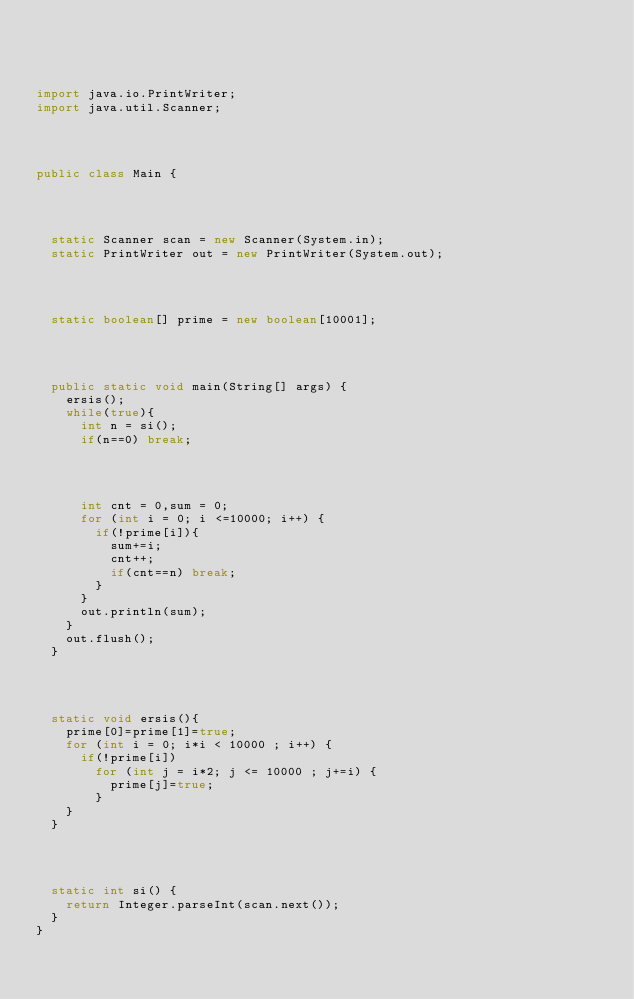<code> <loc_0><loc_0><loc_500><loc_500><_Java_>



import java.io.PrintWriter;
import java.util.Scanner;




public class Main {




	static Scanner scan = new Scanner(System.in);
	static PrintWriter out = new PrintWriter(System.out);




	static boolean[] prime = new boolean[10001];




	public static void main(String[] args) {
		ersis();
		while(true){
			int n = si();
			if(n==0) break;




			int cnt = 0,sum = 0;
			for (int i = 0; i <=10000; i++) {
				if(!prime[i]){
					sum+=i;
					cnt++;
					if(cnt==n) break;
				}
			}
			out.println(sum);
		}
		out.flush();
	}




	static void ersis(){
		prime[0]=prime[1]=true;
		for (int i = 0; i*i < 10000 ; i++) {
			if(!prime[i])
				for (int j = i*2; j <= 10000 ; j+=i) {
					prime[j]=true;
				}
		}
	}




	static int si() {
		return Integer.parseInt(scan.next());
	}
}</code> 